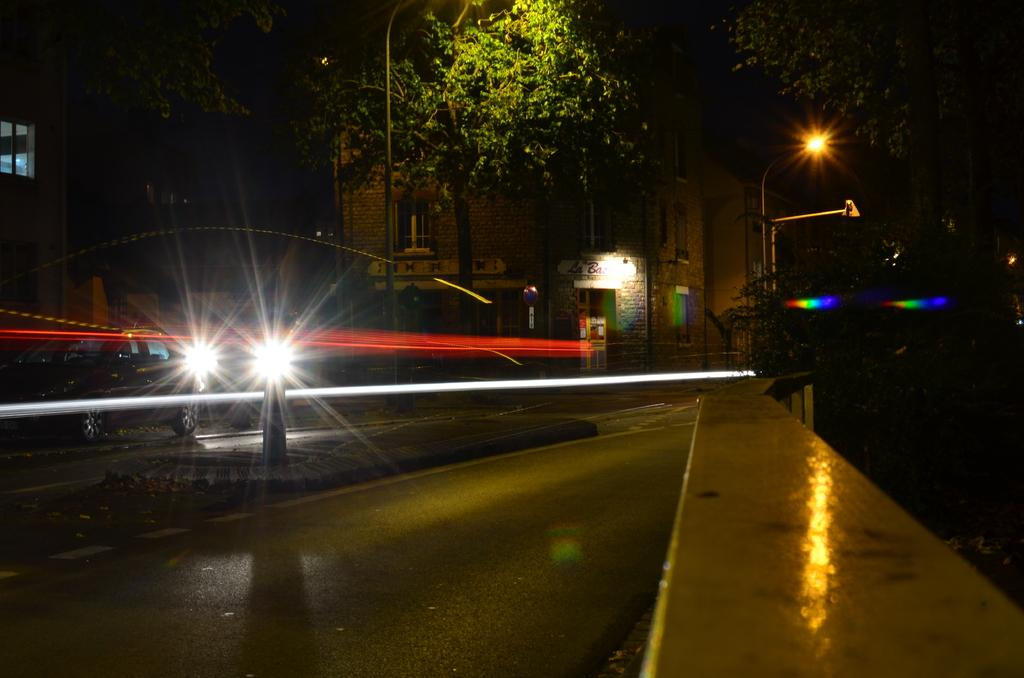What is the main subject of the image? There is a vehicle in the image. What other objects can be seen in the image? There are light poles and trees in the image. How can you describe the lighting in the image? The corners of the image are dark. How many cakes are being shared by the robin and its partner in the image? There are no cakes, robins, or partners present in the image. 